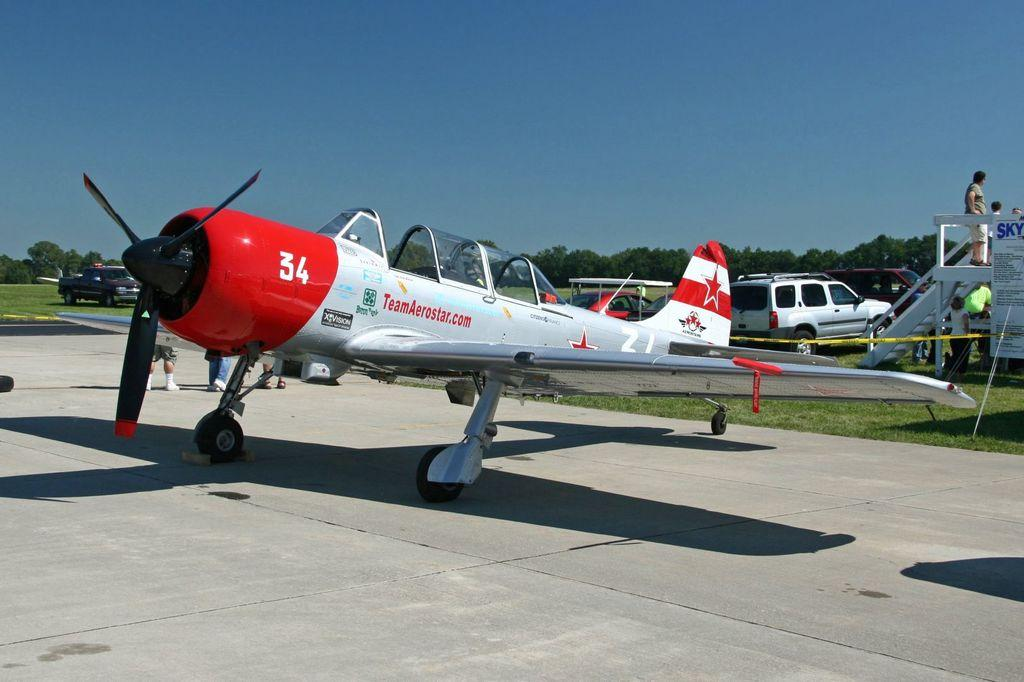<image>
Present a compact description of the photo's key features. Red and white airplane with TeamAerostar logo, XVision logo, and number 34 printed on the front. 